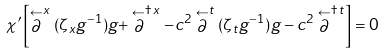Convert formula to latex. <formula><loc_0><loc_0><loc_500><loc_500>\chi ^ { \prime } \left [ \stackrel { \leftarrow } { \partial } ^ { x } ( \zeta _ { x } g ^ { - 1 } ) g + \stackrel { \leftarrow } { \partial } ^ { \dagger \, x } - c ^ { 2 } \stackrel { \leftarrow } { \partial } ^ { t } ( \zeta _ { t } g ^ { - 1 } ) g - c ^ { 2 } \stackrel { \leftarrow } { \partial } ^ { \dagger \, t } \right ] = 0</formula> 